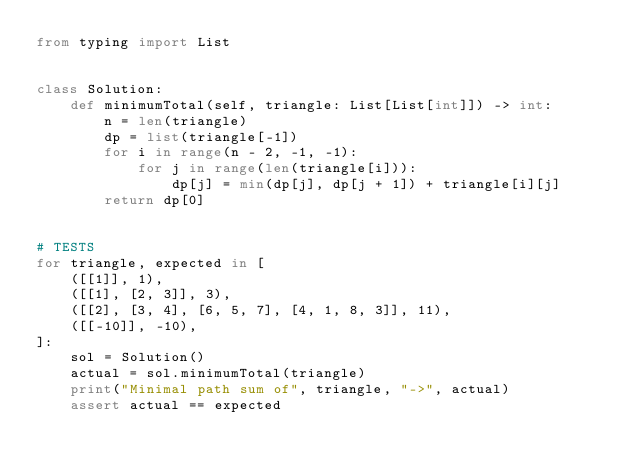Convert code to text. <code><loc_0><loc_0><loc_500><loc_500><_Python_>from typing import List


class Solution:
    def minimumTotal(self, triangle: List[List[int]]) -> int:
        n = len(triangle)
        dp = list(triangle[-1])
        for i in range(n - 2, -1, -1): 
            for j in range(len(triangle[i])):
                dp[j] = min(dp[j], dp[j + 1]) + triangle[i][j]
        return dp[0]


# TESTS
for triangle, expected in [
    ([[1]], 1),
    ([[1], [2, 3]], 3),
    ([[2], [3, 4], [6, 5, 7], [4, 1, 8, 3]], 11),
    ([[-10]], -10),
]:
    sol = Solution()
    actual = sol.minimumTotal(triangle)
    print("Minimal path sum of", triangle, "->", actual)
    assert actual == expected

</code> 